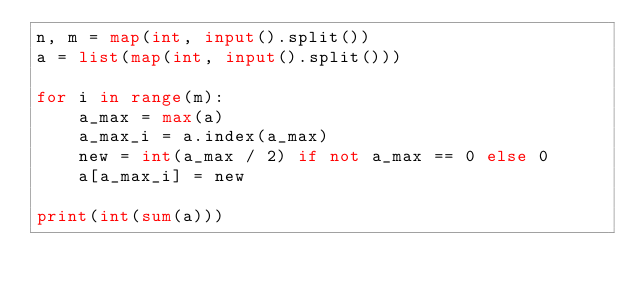<code> <loc_0><loc_0><loc_500><loc_500><_Python_>n, m = map(int, input().split())
a = list(map(int, input().split()))

for i in range(m):
    a_max = max(a)
    a_max_i = a.index(a_max)
    new = int(a_max / 2) if not a_max == 0 else 0
    a[a_max_i] = new

print(int(sum(a)))</code> 